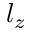<formula> <loc_0><loc_0><loc_500><loc_500>l _ { z }</formula> 